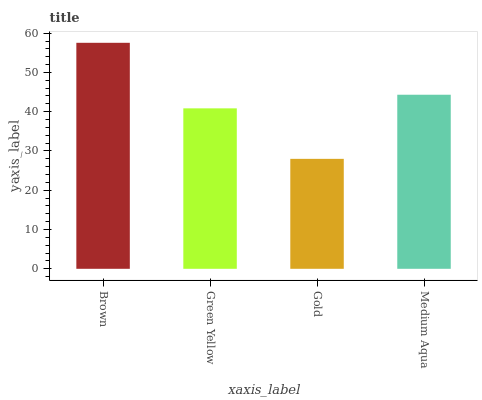Is Gold the minimum?
Answer yes or no. Yes. Is Brown the maximum?
Answer yes or no. Yes. Is Green Yellow the minimum?
Answer yes or no. No. Is Green Yellow the maximum?
Answer yes or no. No. Is Brown greater than Green Yellow?
Answer yes or no. Yes. Is Green Yellow less than Brown?
Answer yes or no. Yes. Is Green Yellow greater than Brown?
Answer yes or no. No. Is Brown less than Green Yellow?
Answer yes or no. No. Is Medium Aqua the high median?
Answer yes or no. Yes. Is Green Yellow the low median?
Answer yes or no. Yes. Is Gold the high median?
Answer yes or no. No. Is Gold the low median?
Answer yes or no. No. 